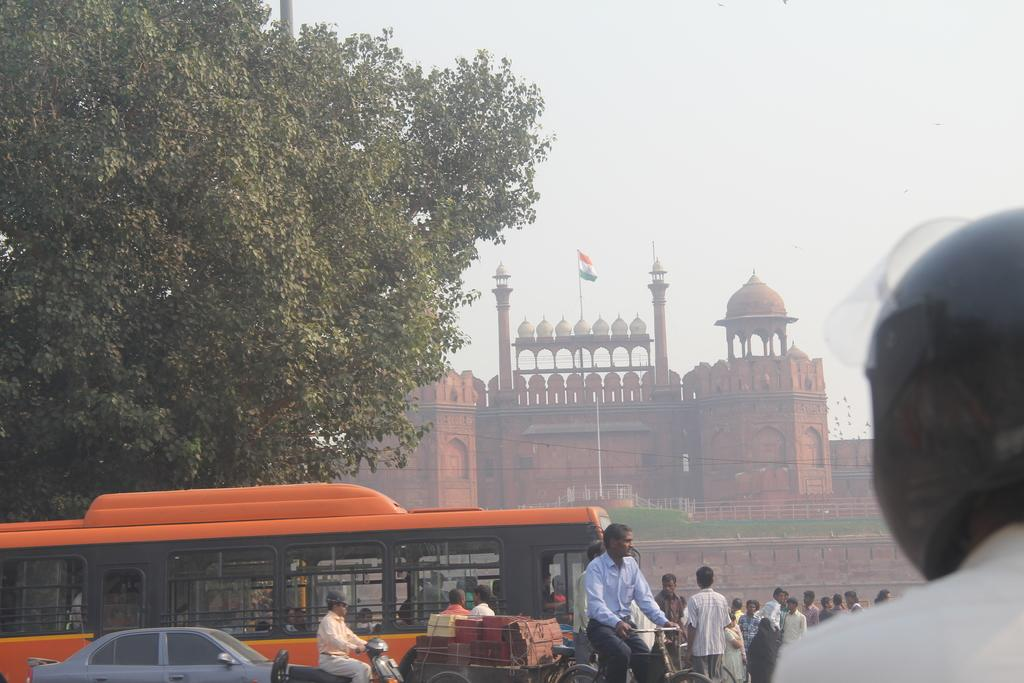What is the main structure in the image? There is a monument in the image. What is attached to the flag post? There is a flag in the image. What type of vegetation can be seen in the image? There are trees in the image. What type of transportation is visible on the road? Motor vehicles are visible on the road in the image. What are some people doing in the image? There are persons sitting on bicycles and standing on the road in the image. What type of thread is being used to sew the curve on the monument? There is no thread or curve mentioned on the monument in the image. 